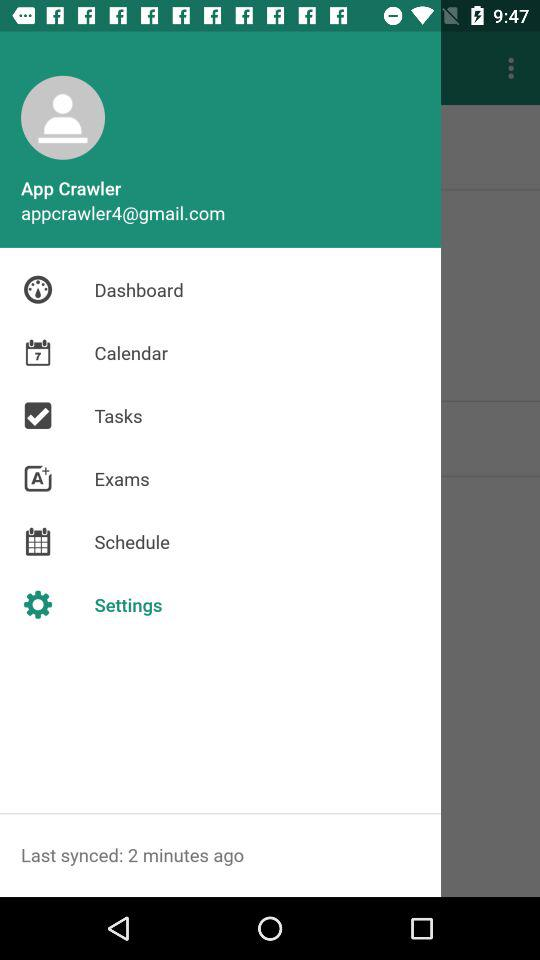What is the user name? The user name is App Crawler. 